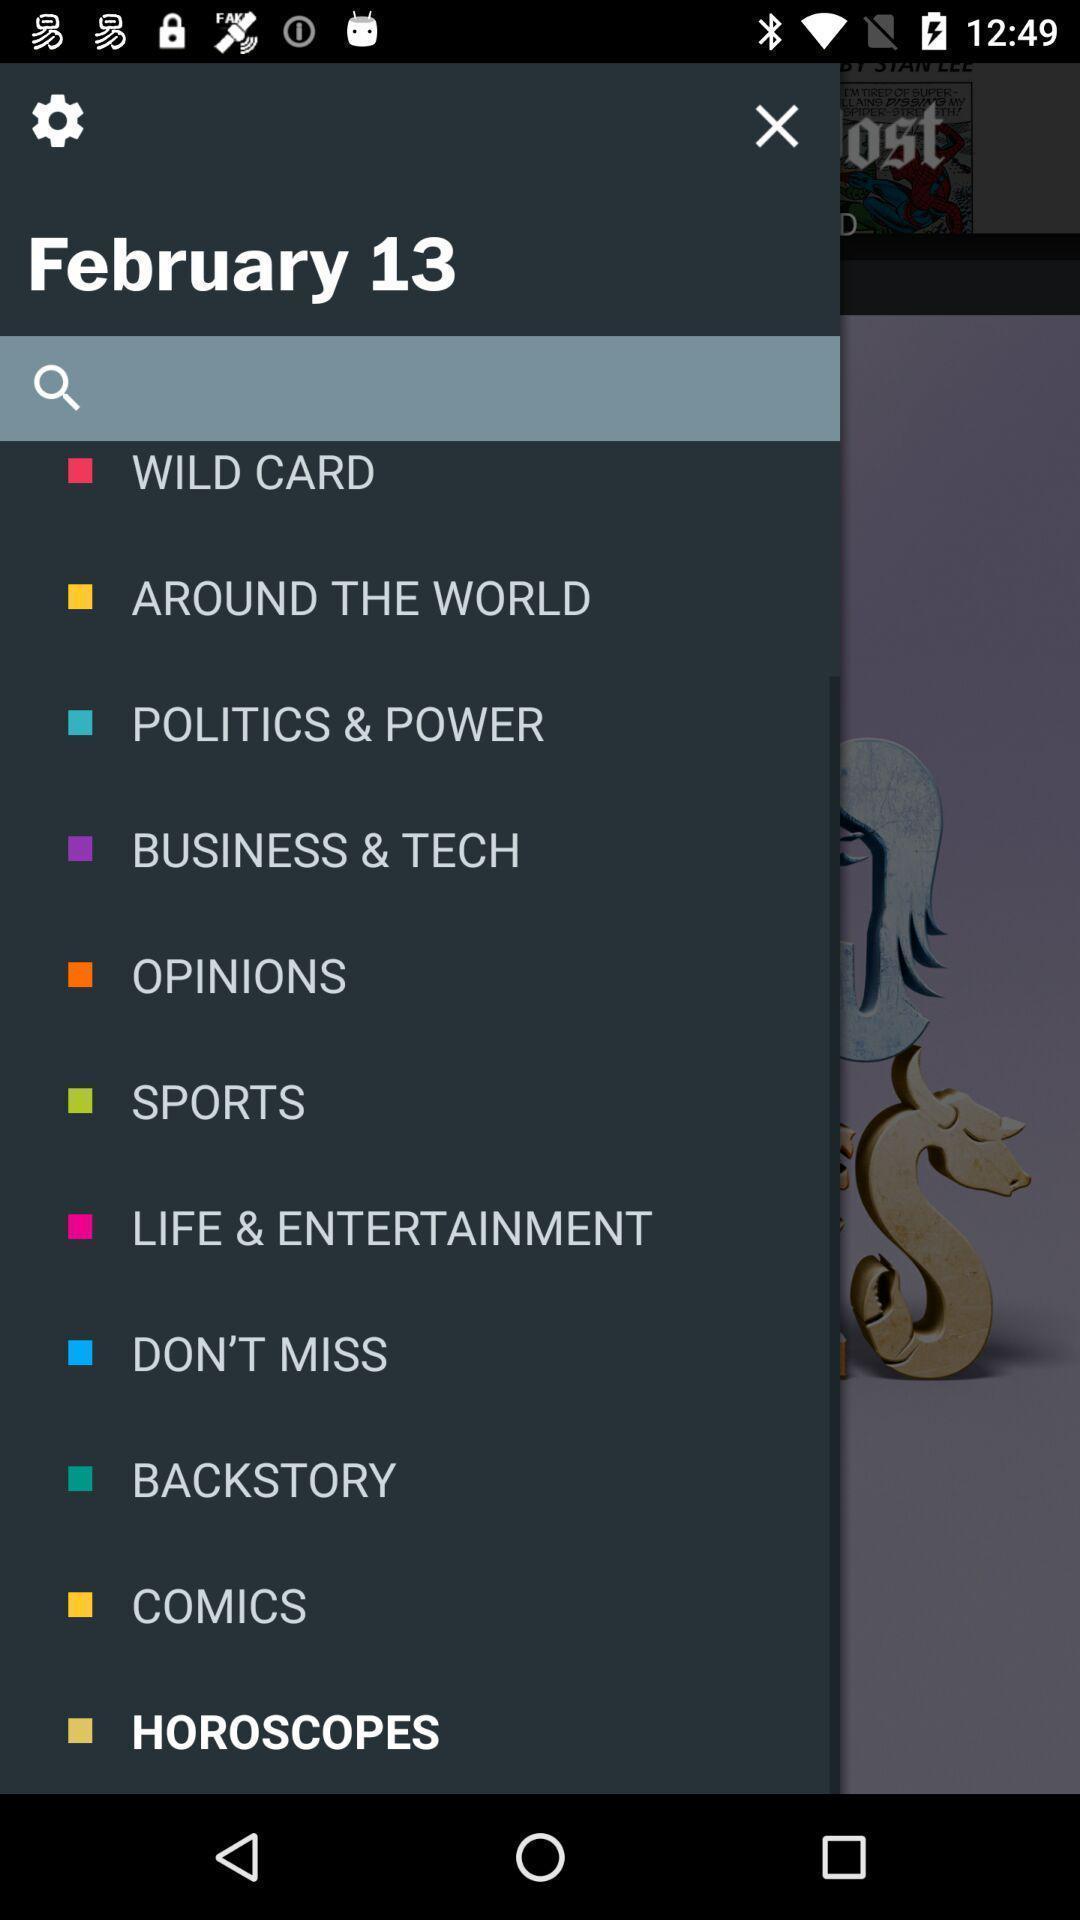What can you discern from this picture? Screen displaying the search bar in app. 